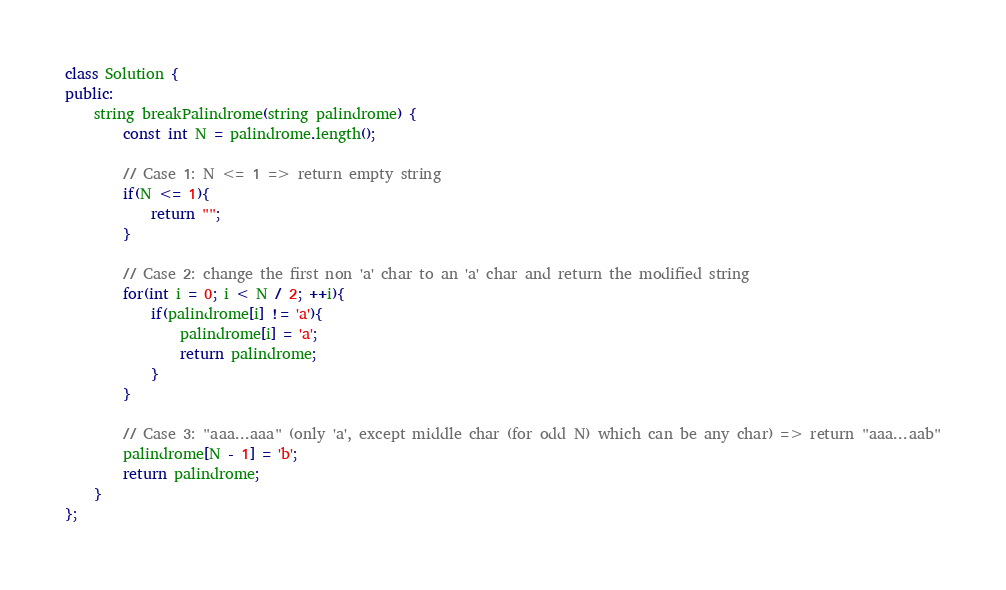Convert code to text. <code><loc_0><loc_0><loc_500><loc_500><_C++_>class Solution {
public:
    string breakPalindrome(string palindrome) {
        const int N = palindrome.length();
        
        // Case 1: N <= 1 => return empty string
        if(N <= 1){
            return "";
        }
        
        // Case 2: change the first non 'a' char to an 'a' char and return the modified string
        for(int i = 0; i < N / 2; ++i){
            if(palindrome[i] != 'a'){
                palindrome[i] = 'a';
                return palindrome;
            }
        }
        
        // Case 3: "aaa...aaa" (only 'a', except middle char (for odd N) which can be any char) => return "aaa...aab"
        palindrome[N - 1] = 'b';
        return palindrome;
    }
};</code> 